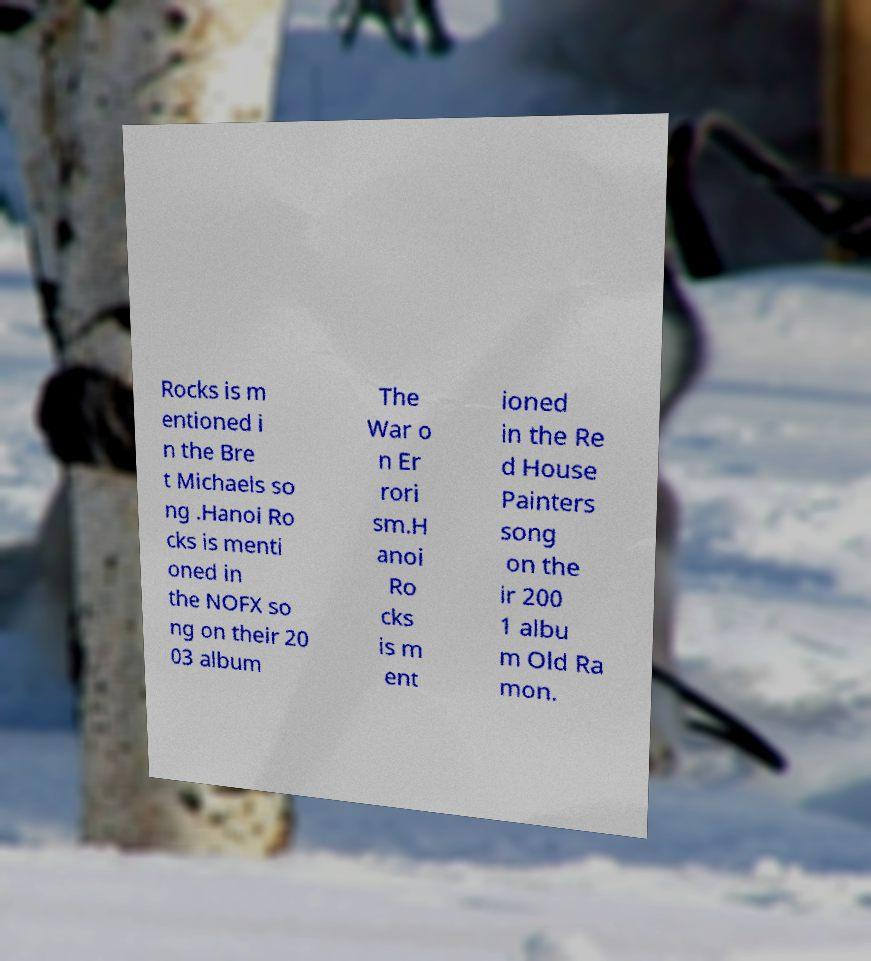For documentation purposes, I need the text within this image transcribed. Could you provide that? Rocks is m entioned i n the Bre t Michaels so ng .Hanoi Ro cks is menti oned in the NOFX so ng on their 20 03 album The War o n Er rori sm.H anoi Ro cks is m ent ioned in the Re d House Painters song on the ir 200 1 albu m Old Ra mon. 